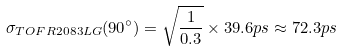<formula> <loc_0><loc_0><loc_500><loc_500>\sigma _ { T O F R 2 0 8 3 L G } ( 9 0 ^ { \circ } ) = \sqrt { \frac { 1 } { 0 . 3 } } \times 3 9 . 6 p s \approx 7 2 . 3 p s</formula> 